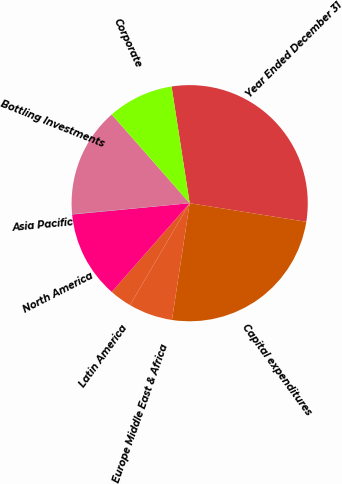Convert chart. <chart><loc_0><loc_0><loc_500><loc_500><pie_chart><fcel>Year Ended December 31<fcel>Capital expenditures<fcel>Europe Middle East & Africa<fcel>Latin America<fcel>North America<fcel>Asia Pacific<fcel>Bottling Investments<fcel>Corporate<nl><fcel>29.97%<fcel>24.88%<fcel>6.03%<fcel>3.04%<fcel>12.01%<fcel>0.04%<fcel>15.01%<fcel>9.02%<nl></chart> 